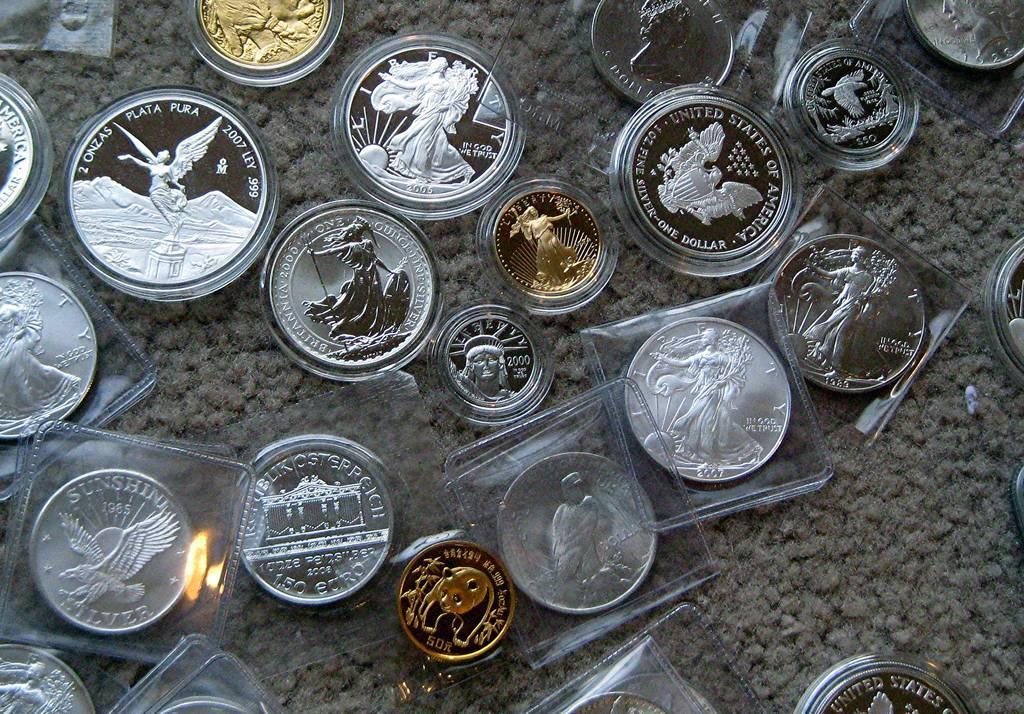Can you describe this image briefly? In this image we can see silver coins and gold coins on the floor. 